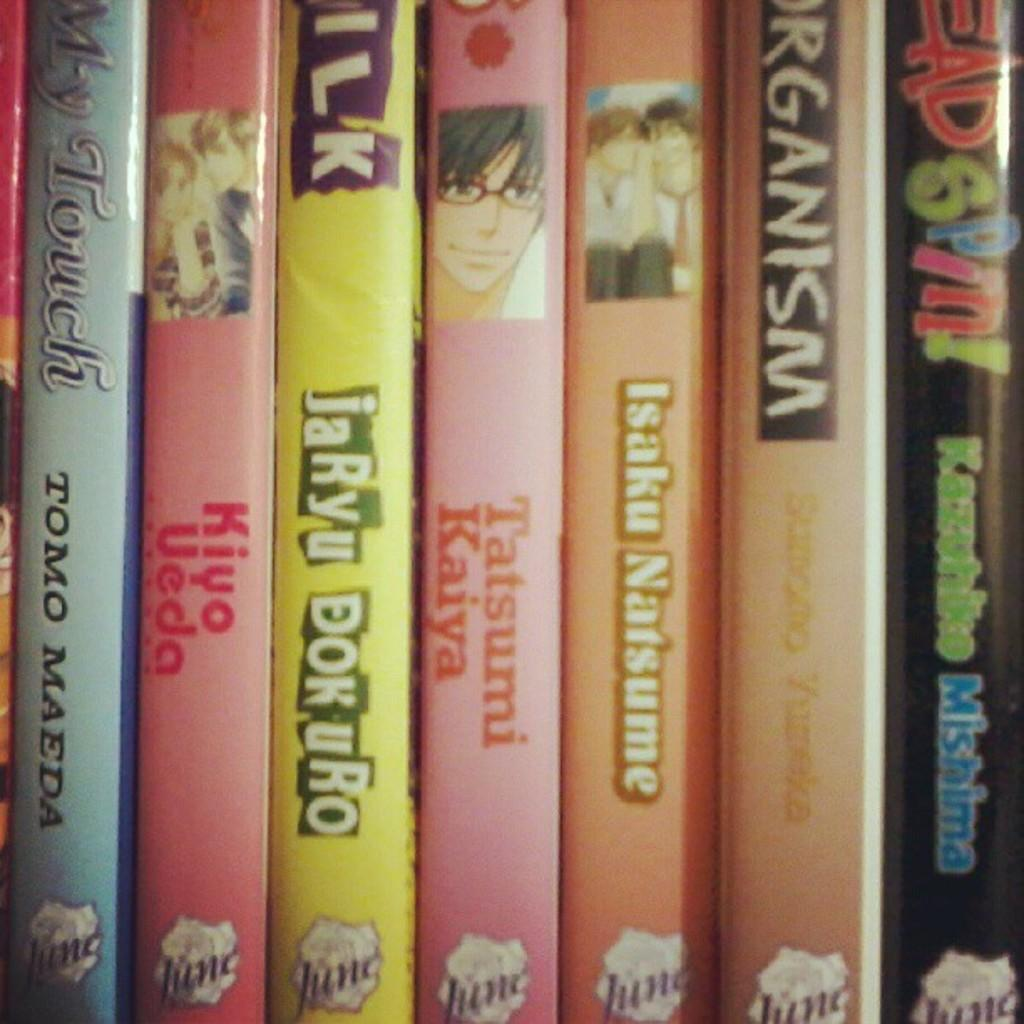Provide a one-sentence caption for the provided image. several books are lined up together, including Head spin. 